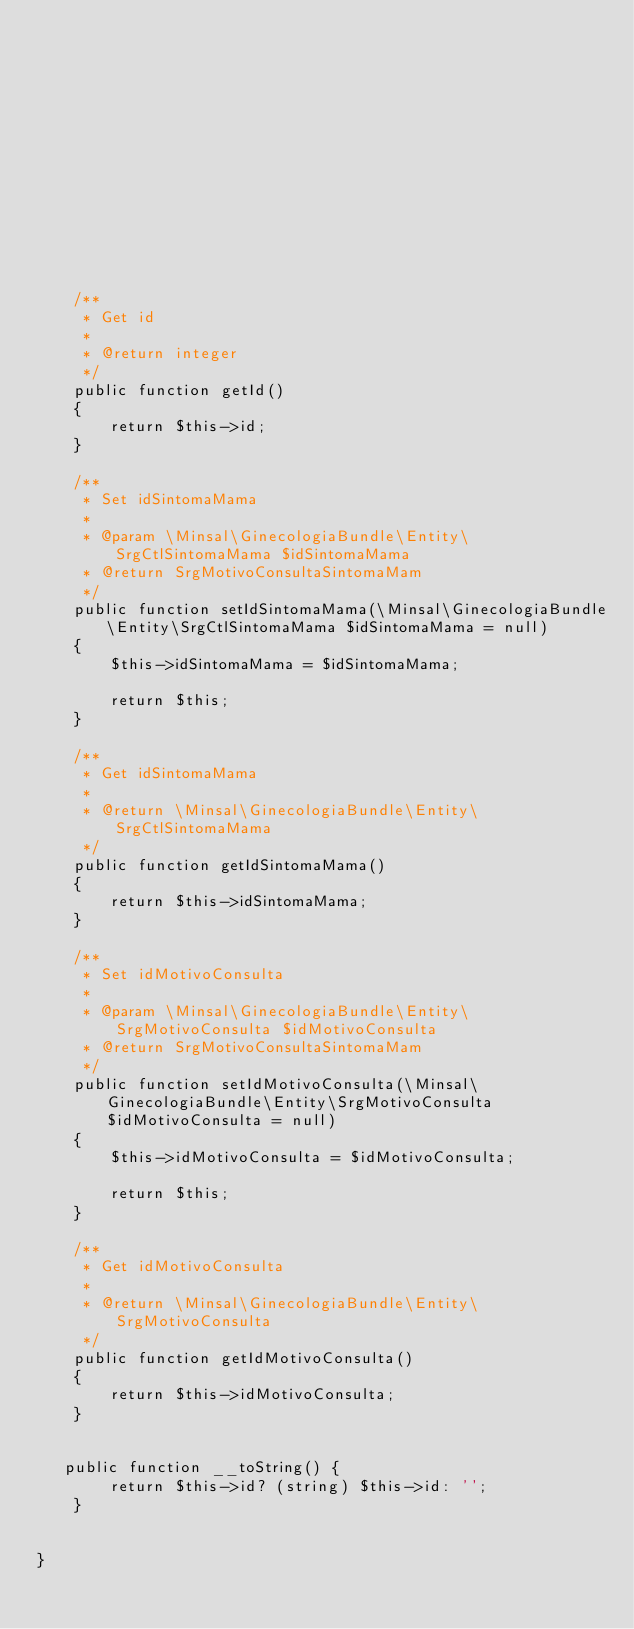<code> <loc_0><loc_0><loc_500><loc_500><_PHP_>













    /**
     * Get id
     *
     * @return integer 
     */
    public function getId()
    {
        return $this->id;
    }

    /**
     * Set idSintomaMama
     *
     * @param \Minsal\GinecologiaBundle\Entity\SrgCtlSintomaMama $idSintomaMama
     * @return SrgMotivoConsultaSintomaMam
     */
    public function setIdSintomaMama(\Minsal\GinecologiaBundle\Entity\SrgCtlSintomaMama $idSintomaMama = null)
    {
        $this->idSintomaMama = $idSintomaMama;

        return $this;
    }

    /**
     * Get idSintomaMama
     *
     * @return \Minsal\GinecologiaBundle\Entity\SrgCtlSintomaMama 
     */
    public function getIdSintomaMama()
    {
        return $this->idSintomaMama;
    }

    /**
     * Set idMotivoConsulta
     *
     * @param \Minsal\GinecologiaBundle\Entity\SrgMotivoConsulta $idMotivoConsulta
     * @return SrgMotivoConsultaSintomaMam
     */
    public function setIdMotivoConsulta(\Minsal\GinecologiaBundle\Entity\SrgMotivoConsulta $idMotivoConsulta = null)
    {
        $this->idMotivoConsulta = $idMotivoConsulta;

        return $this;
    }

    /**
     * Get idMotivoConsulta
     *
     * @return \Minsal\GinecologiaBundle\Entity\SrgMotivoConsulta 
     */
    public function getIdMotivoConsulta()
    {
        return $this->idMotivoConsulta;
    }


   public function __toString() {
        return $this->id? (string) $this->id: ''; 
    }

    
}
</code> 